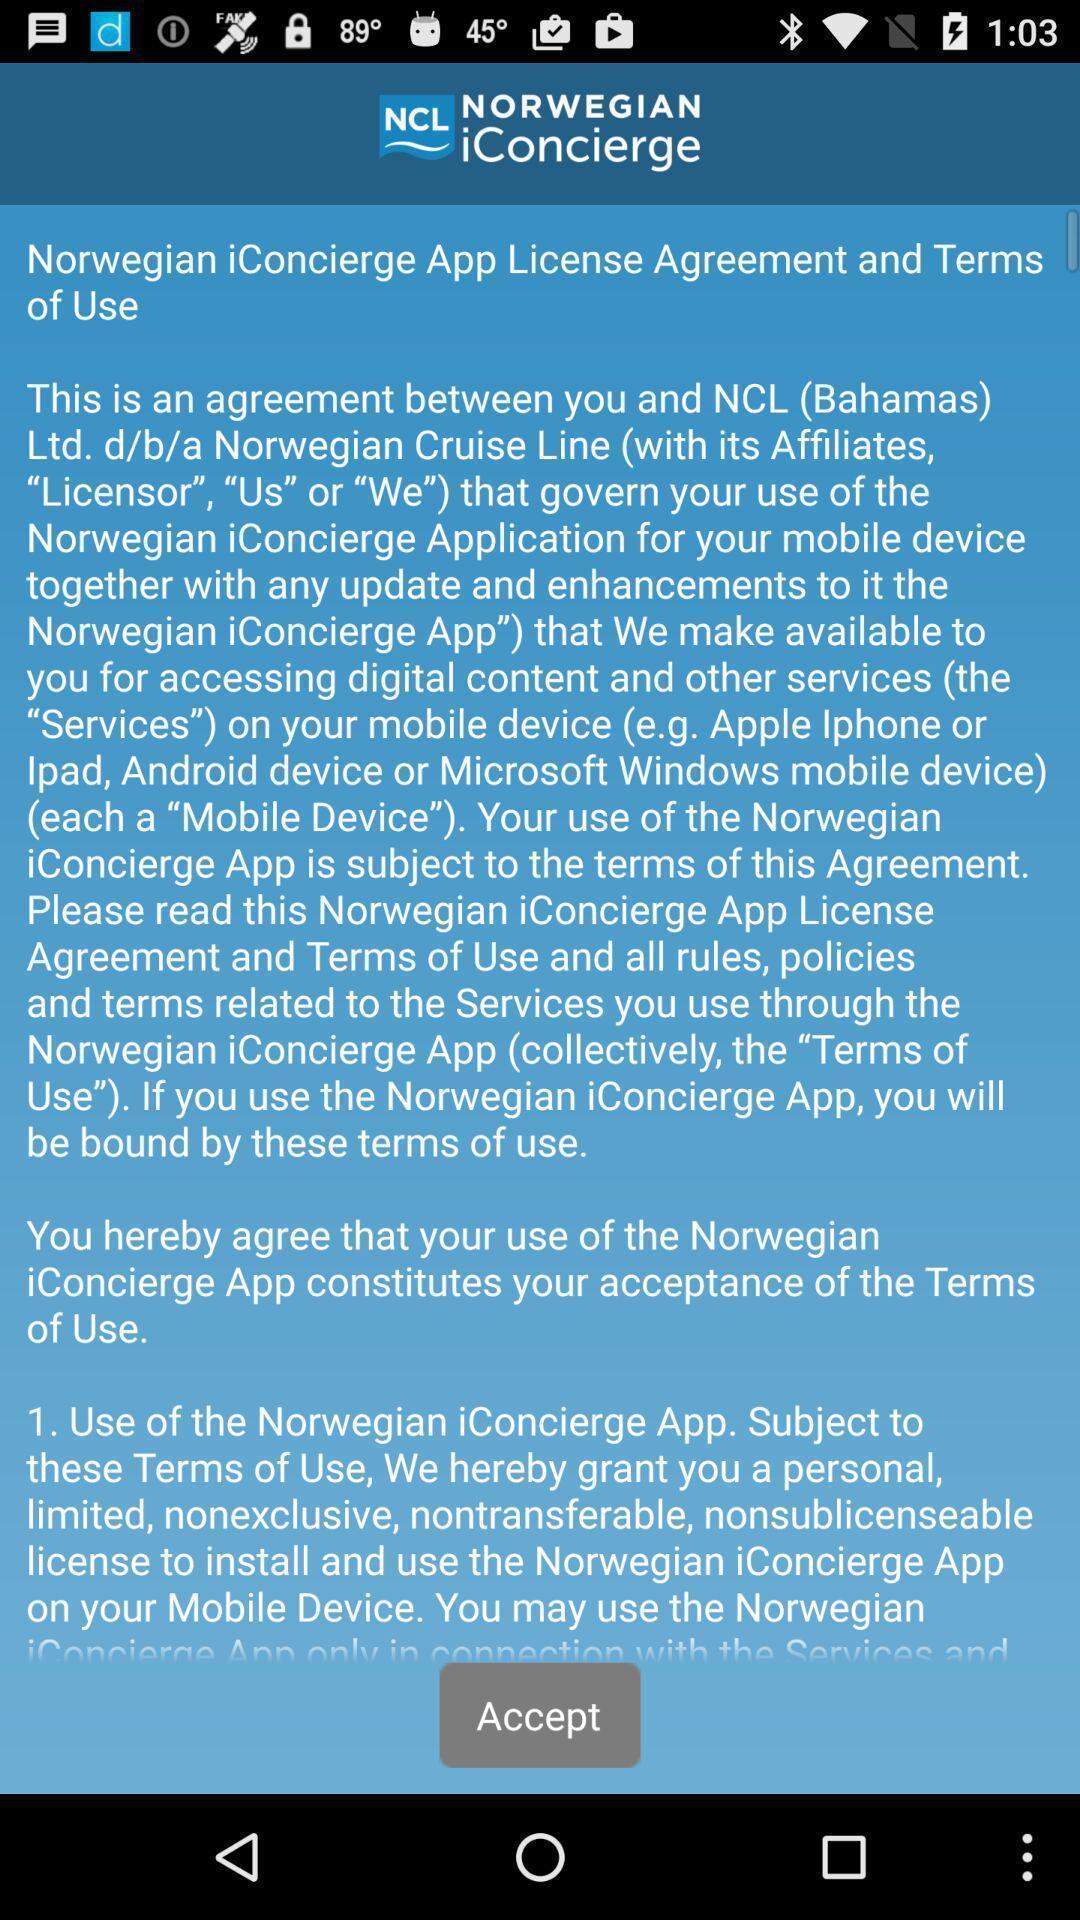Tell me about the visual elements in this screen capture. Page shows license agreement terms of a travel app. 